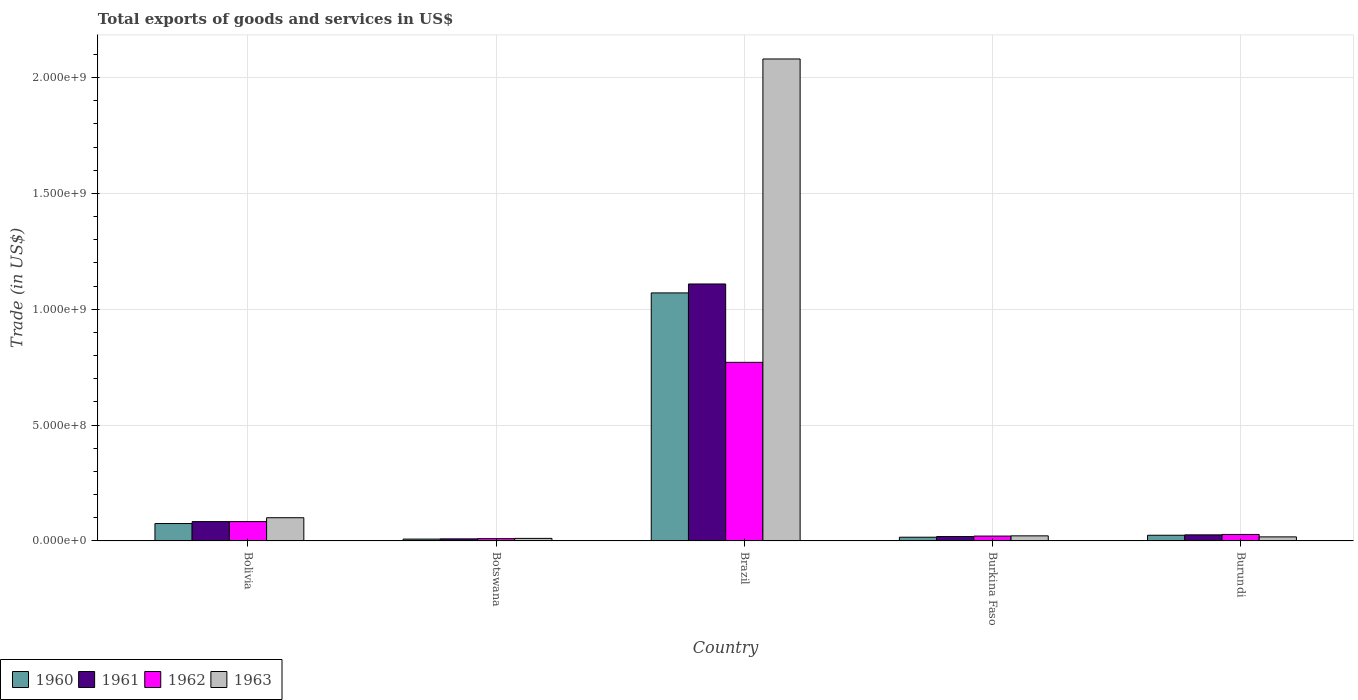How many different coloured bars are there?
Ensure brevity in your answer.  4. How many groups of bars are there?
Provide a succinct answer. 5. How many bars are there on the 3rd tick from the left?
Ensure brevity in your answer.  4. How many bars are there on the 3rd tick from the right?
Make the answer very short. 4. What is the label of the 4th group of bars from the left?
Offer a terse response. Burkina Faso. In how many cases, is the number of bars for a given country not equal to the number of legend labels?
Keep it short and to the point. 0. What is the total exports of goods and services in 1960 in Brazil?
Offer a very short reply. 1.07e+09. Across all countries, what is the maximum total exports of goods and services in 1961?
Give a very brief answer. 1.11e+09. Across all countries, what is the minimum total exports of goods and services in 1962?
Your answer should be compact. 9.95e+06. In which country was the total exports of goods and services in 1962 maximum?
Offer a very short reply. Brazil. In which country was the total exports of goods and services in 1961 minimum?
Keep it short and to the point. Botswana. What is the total total exports of goods and services in 1963 in the graph?
Make the answer very short. 2.23e+09. What is the difference between the total exports of goods and services in 1961 in Bolivia and that in Botswana?
Keep it short and to the point. 7.45e+07. What is the difference between the total exports of goods and services in 1961 in Bolivia and the total exports of goods and services in 1963 in Burundi?
Provide a short and direct response. 6.60e+07. What is the average total exports of goods and services in 1960 per country?
Offer a terse response. 2.39e+08. What is the difference between the total exports of goods and services of/in 1961 and total exports of goods and services of/in 1963 in Bolivia?
Offer a terse response. -1.67e+07. What is the ratio of the total exports of goods and services in 1963 in Bolivia to that in Botswana?
Offer a terse response. 9.07. Is the total exports of goods and services in 1960 in Botswana less than that in Brazil?
Give a very brief answer. Yes. Is the difference between the total exports of goods and services in 1961 in Brazil and Burundi greater than the difference between the total exports of goods and services in 1963 in Brazil and Burundi?
Your answer should be very brief. No. What is the difference between the highest and the second highest total exports of goods and services in 1962?
Offer a terse response. -5.55e+07. What is the difference between the highest and the lowest total exports of goods and services in 1961?
Your response must be concise. 1.10e+09. In how many countries, is the total exports of goods and services in 1961 greater than the average total exports of goods and services in 1961 taken over all countries?
Offer a terse response. 1. Is it the case that in every country, the sum of the total exports of goods and services in 1961 and total exports of goods and services in 1963 is greater than the sum of total exports of goods and services in 1960 and total exports of goods and services in 1962?
Your answer should be compact. No. What does the 3rd bar from the right in Brazil represents?
Your answer should be compact. 1961. Does the graph contain any zero values?
Make the answer very short. No. Where does the legend appear in the graph?
Provide a succinct answer. Bottom left. What is the title of the graph?
Ensure brevity in your answer.  Total exports of goods and services in US$. Does "1998" appear as one of the legend labels in the graph?
Your answer should be very brief. No. What is the label or title of the X-axis?
Your answer should be very brief. Country. What is the label or title of the Y-axis?
Keep it short and to the point. Trade (in US$). What is the Trade (in US$) of 1960 in Bolivia?
Your response must be concise. 7.51e+07. What is the Trade (in US$) in 1961 in Bolivia?
Offer a very short reply. 8.35e+07. What is the Trade (in US$) of 1962 in Bolivia?
Ensure brevity in your answer.  8.35e+07. What is the Trade (in US$) in 1963 in Bolivia?
Your answer should be very brief. 1.00e+08. What is the Trade (in US$) in 1960 in Botswana?
Offer a very short reply. 7.99e+06. What is the Trade (in US$) of 1961 in Botswana?
Offer a terse response. 8.95e+06. What is the Trade (in US$) in 1962 in Botswana?
Make the answer very short. 9.95e+06. What is the Trade (in US$) of 1963 in Botswana?
Ensure brevity in your answer.  1.10e+07. What is the Trade (in US$) in 1960 in Brazil?
Your answer should be compact. 1.07e+09. What is the Trade (in US$) in 1961 in Brazil?
Make the answer very short. 1.11e+09. What is the Trade (in US$) in 1962 in Brazil?
Provide a succinct answer. 7.71e+08. What is the Trade (in US$) in 1963 in Brazil?
Ensure brevity in your answer.  2.08e+09. What is the Trade (in US$) in 1960 in Burkina Faso?
Your answer should be very brief. 1.61e+07. What is the Trade (in US$) of 1961 in Burkina Faso?
Make the answer very short. 1.90e+07. What is the Trade (in US$) in 1962 in Burkina Faso?
Give a very brief answer. 2.10e+07. What is the Trade (in US$) in 1963 in Burkina Faso?
Keep it short and to the point. 2.20e+07. What is the Trade (in US$) in 1960 in Burundi?
Offer a terse response. 2.45e+07. What is the Trade (in US$) of 1961 in Burundi?
Provide a succinct answer. 2.62e+07. What is the Trade (in US$) in 1962 in Burundi?
Give a very brief answer. 2.80e+07. What is the Trade (in US$) in 1963 in Burundi?
Provide a succinct answer. 1.75e+07. Across all countries, what is the maximum Trade (in US$) in 1960?
Provide a short and direct response. 1.07e+09. Across all countries, what is the maximum Trade (in US$) in 1961?
Your response must be concise. 1.11e+09. Across all countries, what is the maximum Trade (in US$) in 1962?
Keep it short and to the point. 7.71e+08. Across all countries, what is the maximum Trade (in US$) of 1963?
Give a very brief answer. 2.08e+09. Across all countries, what is the minimum Trade (in US$) in 1960?
Ensure brevity in your answer.  7.99e+06. Across all countries, what is the minimum Trade (in US$) in 1961?
Your response must be concise. 8.95e+06. Across all countries, what is the minimum Trade (in US$) in 1962?
Offer a terse response. 9.95e+06. Across all countries, what is the minimum Trade (in US$) in 1963?
Give a very brief answer. 1.10e+07. What is the total Trade (in US$) in 1960 in the graph?
Provide a short and direct response. 1.19e+09. What is the total Trade (in US$) of 1961 in the graph?
Offer a terse response. 1.25e+09. What is the total Trade (in US$) of 1962 in the graph?
Provide a succinct answer. 9.13e+08. What is the total Trade (in US$) in 1963 in the graph?
Make the answer very short. 2.23e+09. What is the difference between the Trade (in US$) of 1960 in Bolivia and that in Botswana?
Provide a succinct answer. 6.71e+07. What is the difference between the Trade (in US$) in 1961 in Bolivia and that in Botswana?
Your answer should be very brief. 7.45e+07. What is the difference between the Trade (in US$) of 1962 in Bolivia and that in Botswana?
Give a very brief answer. 7.35e+07. What is the difference between the Trade (in US$) of 1963 in Bolivia and that in Botswana?
Provide a succinct answer. 8.91e+07. What is the difference between the Trade (in US$) in 1960 in Bolivia and that in Brazil?
Give a very brief answer. -9.95e+08. What is the difference between the Trade (in US$) in 1961 in Bolivia and that in Brazil?
Offer a terse response. -1.03e+09. What is the difference between the Trade (in US$) of 1962 in Bolivia and that in Brazil?
Ensure brevity in your answer.  -6.87e+08. What is the difference between the Trade (in US$) in 1963 in Bolivia and that in Brazil?
Your answer should be compact. -1.98e+09. What is the difference between the Trade (in US$) in 1960 in Bolivia and that in Burkina Faso?
Provide a short and direct response. 5.91e+07. What is the difference between the Trade (in US$) of 1961 in Bolivia and that in Burkina Faso?
Your response must be concise. 6.45e+07. What is the difference between the Trade (in US$) of 1962 in Bolivia and that in Burkina Faso?
Your answer should be compact. 6.25e+07. What is the difference between the Trade (in US$) in 1963 in Bolivia and that in Burkina Faso?
Make the answer very short. 7.82e+07. What is the difference between the Trade (in US$) in 1960 in Bolivia and that in Burundi?
Your response must be concise. 5.06e+07. What is the difference between the Trade (in US$) of 1961 in Bolivia and that in Burundi?
Your response must be concise. 5.72e+07. What is the difference between the Trade (in US$) in 1962 in Bolivia and that in Burundi?
Provide a succinct answer. 5.55e+07. What is the difference between the Trade (in US$) of 1963 in Bolivia and that in Burundi?
Your answer should be very brief. 8.27e+07. What is the difference between the Trade (in US$) in 1960 in Botswana and that in Brazil?
Your answer should be very brief. -1.06e+09. What is the difference between the Trade (in US$) in 1961 in Botswana and that in Brazil?
Offer a terse response. -1.10e+09. What is the difference between the Trade (in US$) in 1962 in Botswana and that in Brazil?
Your answer should be very brief. -7.61e+08. What is the difference between the Trade (in US$) in 1963 in Botswana and that in Brazil?
Give a very brief answer. -2.07e+09. What is the difference between the Trade (in US$) in 1960 in Botswana and that in Burkina Faso?
Offer a terse response. -8.08e+06. What is the difference between the Trade (in US$) of 1961 in Botswana and that in Burkina Faso?
Keep it short and to the point. -1.01e+07. What is the difference between the Trade (in US$) of 1962 in Botswana and that in Burkina Faso?
Your answer should be compact. -1.10e+07. What is the difference between the Trade (in US$) of 1963 in Botswana and that in Burkina Faso?
Give a very brief answer. -1.09e+07. What is the difference between the Trade (in US$) in 1960 in Botswana and that in Burundi?
Provide a short and direct response. -1.65e+07. What is the difference between the Trade (in US$) in 1961 in Botswana and that in Burundi?
Your answer should be compact. -1.73e+07. What is the difference between the Trade (in US$) in 1962 in Botswana and that in Burundi?
Your answer should be very brief. -1.80e+07. What is the difference between the Trade (in US$) in 1963 in Botswana and that in Burundi?
Offer a very short reply. -6.46e+06. What is the difference between the Trade (in US$) in 1960 in Brazil and that in Burkina Faso?
Your response must be concise. 1.05e+09. What is the difference between the Trade (in US$) in 1961 in Brazil and that in Burkina Faso?
Offer a very short reply. 1.09e+09. What is the difference between the Trade (in US$) in 1962 in Brazil and that in Burkina Faso?
Your answer should be compact. 7.50e+08. What is the difference between the Trade (in US$) of 1963 in Brazil and that in Burkina Faso?
Your answer should be compact. 2.06e+09. What is the difference between the Trade (in US$) in 1960 in Brazil and that in Burundi?
Your response must be concise. 1.05e+09. What is the difference between the Trade (in US$) in 1961 in Brazil and that in Burundi?
Offer a terse response. 1.08e+09. What is the difference between the Trade (in US$) in 1962 in Brazil and that in Burundi?
Your answer should be very brief. 7.43e+08. What is the difference between the Trade (in US$) of 1963 in Brazil and that in Burundi?
Offer a terse response. 2.06e+09. What is the difference between the Trade (in US$) in 1960 in Burkina Faso and that in Burundi?
Your answer should be very brief. -8.43e+06. What is the difference between the Trade (in US$) in 1961 in Burkina Faso and that in Burundi?
Ensure brevity in your answer.  -7.24e+06. What is the difference between the Trade (in US$) in 1962 in Burkina Faso and that in Burundi?
Make the answer very short. -7.00e+06. What is the difference between the Trade (in US$) of 1963 in Burkina Faso and that in Burundi?
Offer a very short reply. 4.49e+06. What is the difference between the Trade (in US$) of 1960 in Bolivia and the Trade (in US$) of 1961 in Botswana?
Your answer should be very brief. 6.62e+07. What is the difference between the Trade (in US$) in 1960 in Bolivia and the Trade (in US$) in 1962 in Botswana?
Provide a short and direct response. 6.52e+07. What is the difference between the Trade (in US$) of 1960 in Bolivia and the Trade (in US$) of 1963 in Botswana?
Make the answer very short. 6.41e+07. What is the difference between the Trade (in US$) of 1961 in Bolivia and the Trade (in US$) of 1962 in Botswana?
Ensure brevity in your answer.  7.35e+07. What is the difference between the Trade (in US$) of 1961 in Bolivia and the Trade (in US$) of 1963 in Botswana?
Give a very brief answer. 7.24e+07. What is the difference between the Trade (in US$) of 1962 in Bolivia and the Trade (in US$) of 1963 in Botswana?
Keep it short and to the point. 7.24e+07. What is the difference between the Trade (in US$) in 1960 in Bolivia and the Trade (in US$) in 1961 in Brazil?
Offer a very short reply. -1.03e+09. What is the difference between the Trade (in US$) in 1960 in Bolivia and the Trade (in US$) in 1962 in Brazil?
Your answer should be very brief. -6.96e+08. What is the difference between the Trade (in US$) in 1960 in Bolivia and the Trade (in US$) in 1963 in Brazil?
Offer a terse response. -2.01e+09. What is the difference between the Trade (in US$) of 1961 in Bolivia and the Trade (in US$) of 1962 in Brazil?
Your answer should be compact. -6.87e+08. What is the difference between the Trade (in US$) in 1961 in Bolivia and the Trade (in US$) in 1963 in Brazil?
Your answer should be very brief. -2.00e+09. What is the difference between the Trade (in US$) of 1962 in Bolivia and the Trade (in US$) of 1963 in Brazil?
Offer a terse response. -2.00e+09. What is the difference between the Trade (in US$) of 1960 in Bolivia and the Trade (in US$) of 1961 in Burkina Faso?
Your answer should be very brief. 5.61e+07. What is the difference between the Trade (in US$) in 1960 in Bolivia and the Trade (in US$) in 1962 in Burkina Faso?
Your answer should be compact. 5.41e+07. What is the difference between the Trade (in US$) in 1960 in Bolivia and the Trade (in US$) in 1963 in Burkina Faso?
Provide a succinct answer. 5.31e+07. What is the difference between the Trade (in US$) of 1961 in Bolivia and the Trade (in US$) of 1962 in Burkina Faso?
Your response must be concise. 6.25e+07. What is the difference between the Trade (in US$) in 1961 in Bolivia and the Trade (in US$) in 1963 in Burkina Faso?
Provide a short and direct response. 6.15e+07. What is the difference between the Trade (in US$) in 1962 in Bolivia and the Trade (in US$) in 1963 in Burkina Faso?
Your answer should be very brief. 6.15e+07. What is the difference between the Trade (in US$) in 1960 in Bolivia and the Trade (in US$) in 1961 in Burundi?
Offer a terse response. 4.89e+07. What is the difference between the Trade (in US$) of 1960 in Bolivia and the Trade (in US$) of 1962 in Burundi?
Offer a terse response. 4.71e+07. What is the difference between the Trade (in US$) in 1960 in Bolivia and the Trade (in US$) in 1963 in Burundi?
Provide a short and direct response. 5.76e+07. What is the difference between the Trade (in US$) of 1961 in Bolivia and the Trade (in US$) of 1962 in Burundi?
Provide a short and direct response. 5.55e+07. What is the difference between the Trade (in US$) in 1961 in Bolivia and the Trade (in US$) in 1963 in Burundi?
Keep it short and to the point. 6.60e+07. What is the difference between the Trade (in US$) of 1962 in Bolivia and the Trade (in US$) of 1963 in Burundi?
Provide a short and direct response. 6.60e+07. What is the difference between the Trade (in US$) in 1960 in Botswana and the Trade (in US$) in 1961 in Brazil?
Provide a succinct answer. -1.10e+09. What is the difference between the Trade (in US$) of 1960 in Botswana and the Trade (in US$) of 1962 in Brazil?
Keep it short and to the point. -7.63e+08. What is the difference between the Trade (in US$) of 1960 in Botswana and the Trade (in US$) of 1963 in Brazil?
Offer a terse response. -2.07e+09. What is the difference between the Trade (in US$) in 1961 in Botswana and the Trade (in US$) in 1962 in Brazil?
Provide a succinct answer. -7.62e+08. What is the difference between the Trade (in US$) of 1961 in Botswana and the Trade (in US$) of 1963 in Brazil?
Keep it short and to the point. -2.07e+09. What is the difference between the Trade (in US$) of 1962 in Botswana and the Trade (in US$) of 1963 in Brazil?
Ensure brevity in your answer.  -2.07e+09. What is the difference between the Trade (in US$) of 1960 in Botswana and the Trade (in US$) of 1961 in Burkina Faso?
Make the answer very short. -1.10e+07. What is the difference between the Trade (in US$) in 1960 in Botswana and the Trade (in US$) in 1962 in Burkina Faso?
Make the answer very short. -1.30e+07. What is the difference between the Trade (in US$) of 1960 in Botswana and the Trade (in US$) of 1963 in Burkina Faso?
Your answer should be very brief. -1.40e+07. What is the difference between the Trade (in US$) in 1961 in Botswana and the Trade (in US$) in 1962 in Burkina Faso?
Provide a succinct answer. -1.20e+07. What is the difference between the Trade (in US$) in 1961 in Botswana and the Trade (in US$) in 1963 in Burkina Faso?
Your answer should be very brief. -1.30e+07. What is the difference between the Trade (in US$) of 1962 in Botswana and the Trade (in US$) of 1963 in Burkina Faso?
Your response must be concise. -1.20e+07. What is the difference between the Trade (in US$) in 1960 in Botswana and the Trade (in US$) in 1961 in Burundi?
Your answer should be very brief. -1.83e+07. What is the difference between the Trade (in US$) of 1960 in Botswana and the Trade (in US$) of 1962 in Burundi?
Your response must be concise. -2.00e+07. What is the difference between the Trade (in US$) of 1960 in Botswana and the Trade (in US$) of 1963 in Burundi?
Provide a short and direct response. -9.51e+06. What is the difference between the Trade (in US$) in 1961 in Botswana and the Trade (in US$) in 1962 in Burundi?
Your response must be concise. -1.90e+07. What is the difference between the Trade (in US$) of 1961 in Botswana and the Trade (in US$) of 1963 in Burundi?
Keep it short and to the point. -8.55e+06. What is the difference between the Trade (in US$) of 1962 in Botswana and the Trade (in US$) of 1963 in Burundi?
Provide a succinct answer. -7.55e+06. What is the difference between the Trade (in US$) in 1960 in Brazil and the Trade (in US$) in 1961 in Burkina Faso?
Provide a short and direct response. 1.05e+09. What is the difference between the Trade (in US$) of 1960 in Brazil and the Trade (in US$) of 1962 in Burkina Faso?
Offer a very short reply. 1.05e+09. What is the difference between the Trade (in US$) in 1960 in Brazil and the Trade (in US$) in 1963 in Burkina Faso?
Offer a terse response. 1.05e+09. What is the difference between the Trade (in US$) in 1961 in Brazil and the Trade (in US$) in 1962 in Burkina Faso?
Your response must be concise. 1.09e+09. What is the difference between the Trade (in US$) of 1961 in Brazil and the Trade (in US$) of 1963 in Burkina Faso?
Provide a succinct answer. 1.09e+09. What is the difference between the Trade (in US$) of 1962 in Brazil and the Trade (in US$) of 1963 in Burkina Faso?
Your answer should be compact. 7.49e+08. What is the difference between the Trade (in US$) of 1960 in Brazil and the Trade (in US$) of 1961 in Burundi?
Your answer should be compact. 1.04e+09. What is the difference between the Trade (in US$) of 1960 in Brazil and the Trade (in US$) of 1962 in Burundi?
Provide a succinct answer. 1.04e+09. What is the difference between the Trade (in US$) of 1960 in Brazil and the Trade (in US$) of 1963 in Burundi?
Your answer should be very brief. 1.05e+09. What is the difference between the Trade (in US$) in 1961 in Brazil and the Trade (in US$) in 1962 in Burundi?
Provide a short and direct response. 1.08e+09. What is the difference between the Trade (in US$) of 1961 in Brazil and the Trade (in US$) of 1963 in Burundi?
Give a very brief answer. 1.09e+09. What is the difference between the Trade (in US$) of 1962 in Brazil and the Trade (in US$) of 1963 in Burundi?
Offer a very short reply. 7.53e+08. What is the difference between the Trade (in US$) of 1960 in Burkina Faso and the Trade (in US$) of 1961 in Burundi?
Provide a succinct answer. -1.02e+07. What is the difference between the Trade (in US$) of 1960 in Burkina Faso and the Trade (in US$) of 1962 in Burundi?
Make the answer very short. -1.19e+07. What is the difference between the Trade (in US$) in 1960 in Burkina Faso and the Trade (in US$) in 1963 in Burundi?
Your answer should be compact. -1.43e+06. What is the difference between the Trade (in US$) of 1961 in Burkina Faso and the Trade (in US$) of 1962 in Burundi?
Your response must be concise. -8.99e+06. What is the difference between the Trade (in US$) of 1961 in Burkina Faso and the Trade (in US$) of 1963 in Burundi?
Ensure brevity in your answer.  1.51e+06. What is the difference between the Trade (in US$) of 1962 in Burkina Faso and the Trade (in US$) of 1963 in Burundi?
Make the answer very short. 3.50e+06. What is the average Trade (in US$) of 1960 per country?
Give a very brief answer. 2.39e+08. What is the average Trade (in US$) in 1961 per country?
Your answer should be very brief. 2.49e+08. What is the average Trade (in US$) of 1962 per country?
Your answer should be compact. 1.83e+08. What is the average Trade (in US$) of 1963 per country?
Offer a very short reply. 4.46e+08. What is the difference between the Trade (in US$) in 1960 and Trade (in US$) in 1961 in Bolivia?
Your response must be concise. -8.35e+06. What is the difference between the Trade (in US$) in 1960 and Trade (in US$) in 1962 in Bolivia?
Provide a short and direct response. -8.35e+06. What is the difference between the Trade (in US$) of 1960 and Trade (in US$) of 1963 in Bolivia?
Offer a very short reply. -2.50e+07. What is the difference between the Trade (in US$) of 1961 and Trade (in US$) of 1962 in Bolivia?
Your answer should be very brief. 0. What is the difference between the Trade (in US$) in 1961 and Trade (in US$) in 1963 in Bolivia?
Provide a succinct answer. -1.67e+07. What is the difference between the Trade (in US$) of 1962 and Trade (in US$) of 1963 in Bolivia?
Your response must be concise. -1.67e+07. What is the difference between the Trade (in US$) of 1960 and Trade (in US$) of 1961 in Botswana?
Your response must be concise. -9.64e+05. What is the difference between the Trade (in US$) of 1960 and Trade (in US$) of 1962 in Botswana?
Provide a succinct answer. -1.96e+06. What is the difference between the Trade (in US$) of 1960 and Trade (in US$) of 1963 in Botswana?
Make the answer very short. -3.05e+06. What is the difference between the Trade (in US$) of 1961 and Trade (in US$) of 1962 in Botswana?
Offer a terse response. -9.99e+05. What is the difference between the Trade (in US$) of 1961 and Trade (in US$) of 1963 in Botswana?
Give a very brief answer. -2.09e+06. What is the difference between the Trade (in US$) of 1962 and Trade (in US$) of 1963 in Botswana?
Your response must be concise. -1.09e+06. What is the difference between the Trade (in US$) in 1960 and Trade (in US$) in 1961 in Brazil?
Offer a very short reply. -3.86e+07. What is the difference between the Trade (in US$) in 1960 and Trade (in US$) in 1962 in Brazil?
Make the answer very short. 3.00e+08. What is the difference between the Trade (in US$) of 1960 and Trade (in US$) of 1963 in Brazil?
Keep it short and to the point. -1.01e+09. What is the difference between the Trade (in US$) in 1961 and Trade (in US$) in 1962 in Brazil?
Provide a succinct answer. 3.38e+08. What is the difference between the Trade (in US$) of 1961 and Trade (in US$) of 1963 in Brazil?
Your answer should be very brief. -9.71e+08. What is the difference between the Trade (in US$) of 1962 and Trade (in US$) of 1963 in Brazil?
Make the answer very short. -1.31e+09. What is the difference between the Trade (in US$) of 1960 and Trade (in US$) of 1961 in Burkina Faso?
Offer a terse response. -2.95e+06. What is the difference between the Trade (in US$) in 1960 and Trade (in US$) in 1962 in Burkina Faso?
Provide a succinct answer. -4.93e+06. What is the difference between the Trade (in US$) of 1960 and Trade (in US$) of 1963 in Burkina Faso?
Keep it short and to the point. -5.92e+06. What is the difference between the Trade (in US$) in 1961 and Trade (in US$) in 1962 in Burkina Faso?
Provide a succinct answer. -1.98e+06. What is the difference between the Trade (in US$) in 1961 and Trade (in US$) in 1963 in Burkina Faso?
Provide a succinct answer. -2.97e+06. What is the difference between the Trade (in US$) of 1962 and Trade (in US$) of 1963 in Burkina Faso?
Keep it short and to the point. -9.88e+05. What is the difference between the Trade (in US$) of 1960 and Trade (in US$) of 1961 in Burundi?
Provide a succinct answer. -1.75e+06. What is the difference between the Trade (in US$) in 1960 and Trade (in US$) in 1962 in Burundi?
Offer a terse response. -3.50e+06. What is the difference between the Trade (in US$) of 1960 and Trade (in US$) of 1963 in Burundi?
Offer a terse response. 7.00e+06. What is the difference between the Trade (in US$) of 1961 and Trade (in US$) of 1962 in Burundi?
Ensure brevity in your answer.  -1.75e+06. What is the difference between the Trade (in US$) of 1961 and Trade (in US$) of 1963 in Burundi?
Your response must be concise. 8.75e+06. What is the difference between the Trade (in US$) in 1962 and Trade (in US$) in 1963 in Burundi?
Keep it short and to the point. 1.05e+07. What is the ratio of the Trade (in US$) in 1960 in Bolivia to that in Botswana?
Keep it short and to the point. 9.4. What is the ratio of the Trade (in US$) of 1961 in Bolivia to that in Botswana?
Give a very brief answer. 9.32. What is the ratio of the Trade (in US$) of 1962 in Bolivia to that in Botswana?
Keep it short and to the point. 8.39. What is the ratio of the Trade (in US$) of 1963 in Bolivia to that in Botswana?
Offer a very short reply. 9.07. What is the ratio of the Trade (in US$) of 1960 in Bolivia to that in Brazil?
Give a very brief answer. 0.07. What is the ratio of the Trade (in US$) of 1961 in Bolivia to that in Brazil?
Ensure brevity in your answer.  0.08. What is the ratio of the Trade (in US$) in 1962 in Bolivia to that in Brazil?
Provide a succinct answer. 0.11. What is the ratio of the Trade (in US$) in 1963 in Bolivia to that in Brazil?
Give a very brief answer. 0.05. What is the ratio of the Trade (in US$) in 1960 in Bolivia to that in Burkina Faso?
Your response must be concise. 4.68. What is the ratio of the Trade (in US$) in 1961 in Bolivia to that in Burkina Faso?
Your answer should be very brief. 4.39. What is the ratio of the Trade (in US$) of 1962 in Bolivia to that in Burkina Faso?
Give a very brief answer. 3.98. What is the ratio of the Trade (in US$) of 1963 in Bolivia to that in Burkina Faso?
Ensure brevity in your answer.  4.56. What is the ratio of the Trade (in US$) in 1960 in Bolivia to that in Burundi?
Your answer should be compact. 3.07. What is the ratio of the Trade (in US$) in 1961 in Bolivia to that in Burundi?
Provide a short and direct response. 3.18. What is the ratio of the Trade (in US$) of 1962 in Bolivia to that in Burundi?
Ensure brevity in your answer.  2.98. What is the ratio of the Trade (in US$) in 1963 in Bolivia to that in Burundi?
Your answer should be very brief. 5.72. What is the ratio of the Trade (in US$) of 1960 in Botswana to that in Brazil?
Give a very brief answer. 0.01. What is the ratio of the Trade (in US$) of 1961 in Botswana to that in Brazil?
Make the answer very short. 0.01. What is the ratio of the Trade (in US$) of 1962 in Botswana to that in Brazil?
Make the answer very short. 0.01. What is the ratio of the Trade (in US$) in 1963 in Botswana to that in Brazil?
Offer a terse response. 0.01. What is the ratio of the Trade (in US$) in 1960 in Botswana to that in Burkina Faso?
Your answer should be very brief. 0.5. What is the ratio of the Trade (in US$) in 1961 in Botswana to that in Burkina Faso?
Keep it short and to the point. 0.47. What is the ratio of the Trade (in US$) of 1962 in Botswana to that in Burkina Faso?
Ensure brevity in your answer.  0.47. What is the ratio of the Trade (in US$) in 1963 in Botswana to that in Burkina Faso?
Give a very brief answer. 0.5. What is the ratio of the Trade (in US$) of 1960 in Botswana to that in Burundi?
Keep it short and to the point. 0.33. What is the ratio of the Trade (in US$) in 1961 in Botswana to that in Burundi?
Your response must be concise. 0.34. What is the ratio of the Trade (in US$) of 1962 in Botswana to that in Burundi?
Offer a very short reply. 0.36. What is the ratio of the Trade (in US$) of 1963 in Botswana to that in Burundi?
Your answer should be very brief. 0.63. What is the ratio of the Trade (in US$) of 1960 in Brazil to that in Burkina Faso?
Make the answer very short. 66.63. What is the ratio of the Trade (in US$) of 1961 in Brazil to that in Burkina Faso?
Your response must be concise. 58.33. What is the ratio of the Trade (in US$) in 1962 in Brazil to that in Burkina Faso?
Offer a terse response. 36.71. What is the ratio of the Trade (in US$) of 1963 in Brazil to that in Burkina Faso?
Offer a very short reply. 94.62. What is the ratio of the Trade (in US$) in 1960 in Brazil to that in Burundi?
Give a very brief answer. 43.7. What is the ratio of the Trade (in US$) in 1961 in Brazil to that in Burundi?
Ensure brevity in your answer.  42.25. What is the ratio of the Trade (in US$) in 1962 in Brazil to that in Burundi?
Make the answer very short. 27.53. What is the ratio of the Trade (in US$) of 1963 in Brazil to that in Burundi?
Provide a succinct answer. 118.88. What is the ratio of the Trade (in US$) of 1960 in Burkina Faso to that in Burundi?
Keep it short and to the point. 0.66. What is the ratio of the Trade (in US$) in 1961 in Burkina Faso to that in Burundi?
Make the answer very short. 0.72. What is the ratio of the Trade (in US$) of 1962 in Burkina Faso to that in Burundi?
Your answer should be compact. 0.75. What is the ratio of the Trade (in US$) of 1963 in Burkina Faso to that in Burundi?
Your answer should be very brief. 1.26. What is the difference between the highest and the second highest Trade (in US$) of 1960?
Make the answer very short. 9.95e+08. What is the difference between the highest and the second highest Trade (in US$) of 1961?
Provide a short and direct response. 1.03e+09. What is the difference between the highest and the second highest Trade (in US$) of 1962?
Your answer should be very brief. 6.87e+08. What is the difference between the highest and the second highest Trade (in US$) in 1963?
Keep it short and to the point. 1.98e+09. What is the difference between the highest and the lowest Trade (in US$) in 1960?
Keep it short and to the point. 1.06e+09. What is the difference between the highest and the lowest Trade (in US$) in 1961?
Give a very brief answer. 1.10e+09. What is the difference between the highest and the lowest Trade (in US$) of 1962?
Your answer should be very brief. 7.61e+08. What is the difference between the highest and the lowest Trade (in US$) of 1963?
Ensure brevity in your answer.  2.07e+09. 